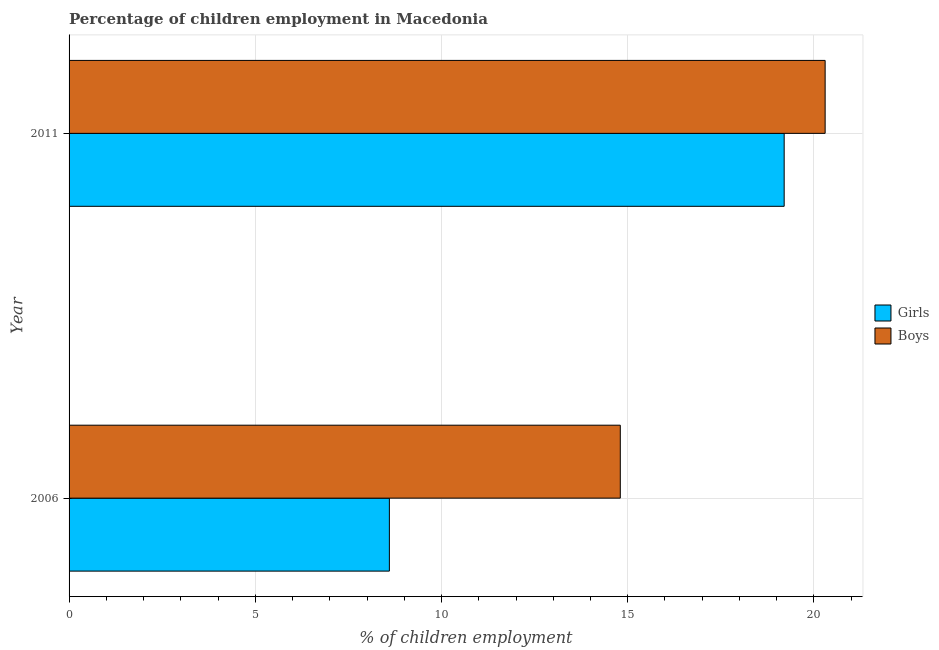How many different coloured bars are there?
Your response must be concise. 2. How many groups of bars are there?
Your response must be concise. 2. Are the number of bars per tick equal to the number of legend labels?
Offer a terse response. Yes. How many bars are there on the 1st tick from the top?
Your response must be concise. 2. What is the percentage of employed girls in 2006?
Offer a terse response. 8.6. Across all years, what is the maximum percentage of employed boys?
Give a very brief answer. 20.3. Across all years, what is the minimum percentage of employed boys?
Your response must be concise. 14.8. In which year was the percentage of employed boys maximum?
Keep it short and to the point. 2011. In which year was the percentage of employed girls minimum?
Make the answer very short. 2006. What is the total percentage of employed girls in the graph?
Offer a terse response. 27.8. What is the difference between the percentage of employed boys in 2006 and that in 2011?
Offer a very short reply. -5.5. What is the difference between the percentage of employed boys in 2006 and the percentage of employed girls in 2011?
Provide a short and direct response. -4.4. What is the ratio of the percentage of employed boys in 2006 to that in 2011?
Your response must be concise. 0.73. In how many years, is the percentage of employed boys greater than the average percentage of employed boys taken over all years?
Give a very brief answer. 1. What does the 2nd bar from the top in 2006 represents?
Offer a terse response. Girls. What does the 1st bar from the bottom in 2006 represents?
Keep it short and to the point. Girls. Are all the bars in the graph horizontal?
Your response must be concise. Yes. How many years are there in the graph?
Ensure brevity in your answer.  2. Does the graph contain any zero values?
Provide a short and direct response. No. Does the graph contain grids?
Make the answer very short. Yes. Where does the legend appear in the graph?
Provide a succinct answer. Center right. How are the legend labels stacked?
Keep it short and to the point. Vertical. What is the title of the graph?
Your answer should be very brief. Percentage of children employment in Macedonia. What is the label or title of the X-axis?
Offer a terse response. % of children employment. What is the label or title of the Y-axis?
Your response must be concise. Year. What is the % of children employment of Boys in 2011?
Offer a very short reply. 20.3. Across all years, what is the maximum % of children employment in Boys?
Keep it short and to the point. 20.3. Across all years, what is the minimum % of children employment of Girls?
Offer a terse response. 8.6. What is the total % of children employment in Girls in the graph?
Your response must be concise. 27.8. What is the total % of children employment in Boys in the graph?
Provide a succinct answer. 35.1. What is the difference between the % of children employment of Girls in 2006 and that in 2011?
Your answer should be very brief. -10.6. What is the average % of children employment in Girls per year?
Your answer should be very brief. 13.9. What is the average % of children employment of Boys per year?
Make the answer very short. 17.55. In the year 2006, what is the difference between the % of children employment of Girls and % of children employment of Boys?
Give a very brief answer. -6.2. What is the ratio of the % of children employment of Girls in 2006 to that in 2011?
Your answer should be very brief. 0.45. What is the ratio of the % of children employment of Boys in 2006 to that in 2011?
Provide a short and direct response. 0.73. What is the difference between the highest and the second highest % of children employment in Boys?
Offer a very short reply. 5.5. What is the difference between the highest and the lowest % of children employment in Girls?
Keep it short and to the point. 10.6. What is the difference between the highest and the lowest % of children employment of Boys?
Keep it short and to the point. 5.5. 